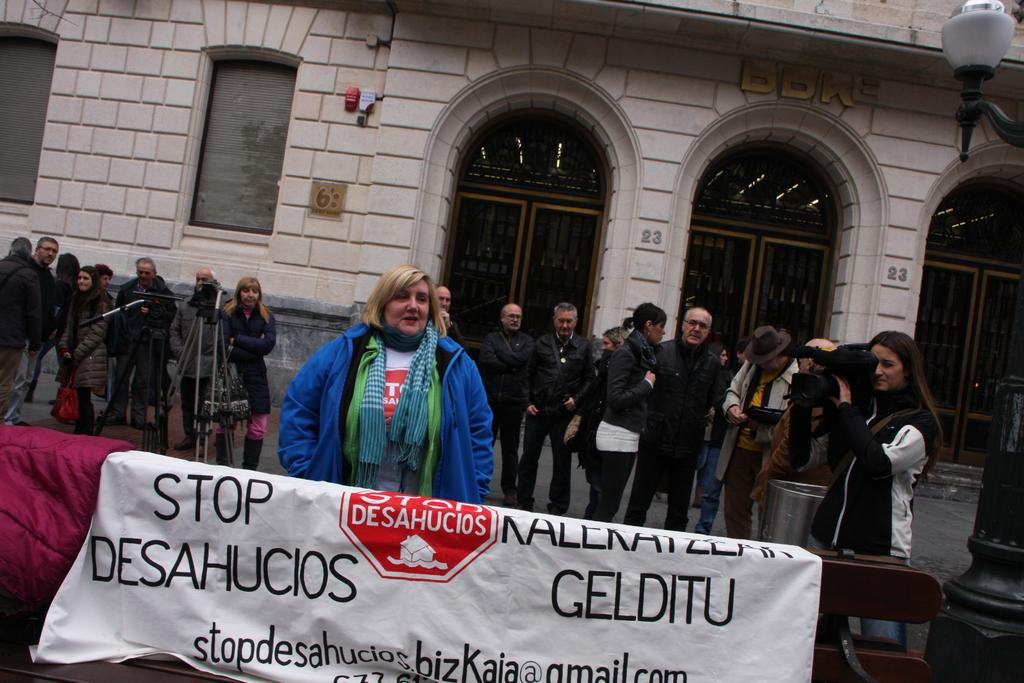How many people are in the image? There is a group of people in the image, but the exact number cannot be determined from the provided facts. What object is used for capturing images in the image? There is a camera in the image. What piece of furniture is present in the image? There is a table in the image. What type of items can be seen in the image? There are clothes in the image. What can be seen in the background of the image? There is a building, doors, windows, and a lamp in the background of the image. What type of cabbage is being used as a prop in the image? There is no cabbage present in the image. What year is the image taken in? The provided facts do not include any information about the year the image was taken. 